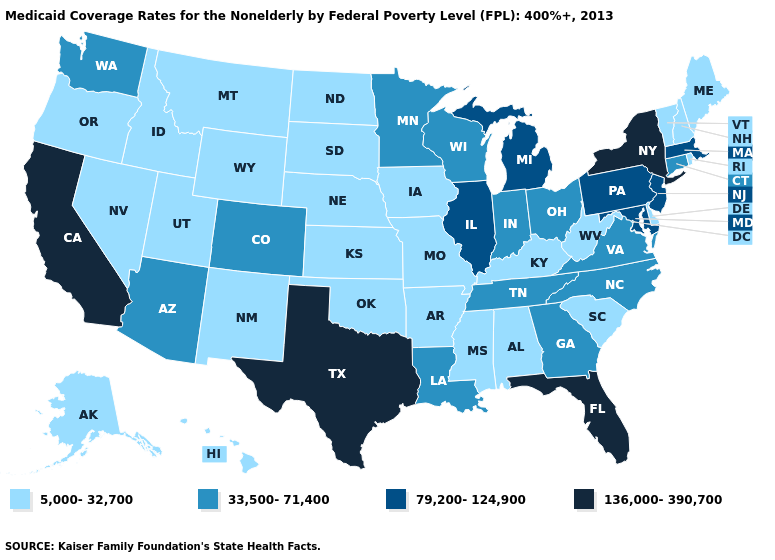Does New York have a higher value than Virginia?
Concise answer only. Yes. Name the states that have a value in the range 33,500-71,400?
Be succinct. Arizona, Colorado, Connecticut, Georgia, Indiana, Louisiana, Minnesota, North Carolina, Ohio, Tennessee, Virginia, Washington, Wisconsin. Does the first symbol in the legend represent the smallest category?
Write a very short answer. Yes. What is the value of Iowa?
Answer briefly. 5,000-32,700. Among the states that border Ohio , does Pennsylvania have the highest value?
Give a very brief answer. Yes. What is the highest value in states that border Alabama?
Short answer required. 136,000-390,700. What is the value of New Jersey?
Keep it brief. 79,200-124,900. What is the lowest value in the West?
Write a very short answer. 5,000-32,700. Among the states that border Nevada , does Arizona have the lowest value?
Short answer required. No. What is the highest value in states that border Texas?
Write a very short answer. 33,500-71,400. Which states have the lowest value in the MidWest?
Quick response, please. Iowa, Kansas, Missouri, Nebraska, North Dakota, South Dakota. Name the states that have a value in the range 136,000-390,700?
Keep it brief. California, Florida, New York, Texas. What is the lowest value in states that border Vermont?
Quick response, please. 5,000-32,700. What is the value of Maine?
Short answer required. 5,000-32,700. What is the value of Washington?
Short answer required. 33,500-71,400. 